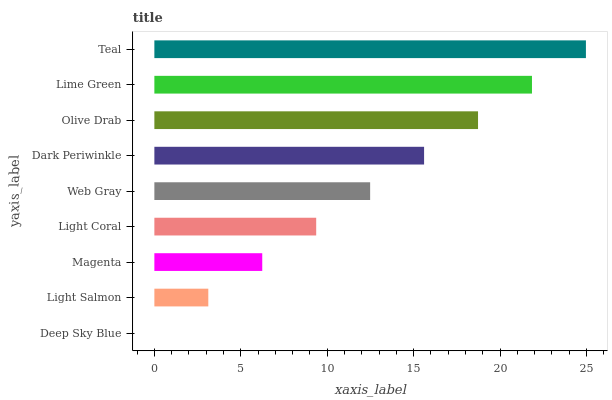Is Deep Sky Blue the minimum?
Answer yes or no. Yes. Is Teal the maximum?
Answer yes or no. Yes. Is Light Salmon the minimum?
Answer yes or no. No. Is Light Salmon the maximum?
Answer yes or no. No. Is Light Salmon greater than Deep Sky Blue?
Answer yes or no. Yes. Is Deep Sky Blue less than Light Salmon?
Answer yes or no. Yes. Is Deep Sky Blue greater than Light Salmon?
Answer yes or no. No. Is Light Salmon less than Deep Sky Blue?
Answer yes or no. No. Is Web Gray the high median?
Answer yes or no. Yes. Is Web Gray the low median?
Answer yes or no. Yes. Is Olive Drab the high median?
Answer yes or no. No. Is Light Salmon the low median?
Answer yes or no. No. 